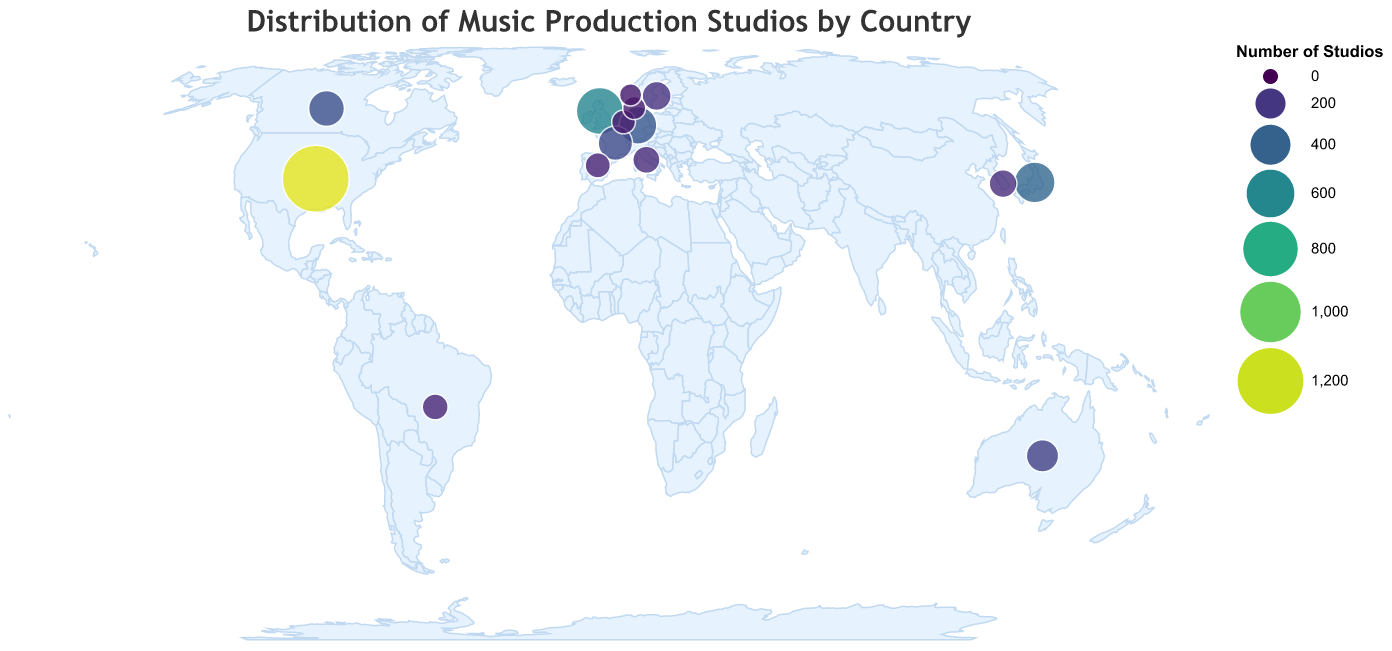How many countries are displayed in the figure? Count each data point in the figure to determine the total number of countries represented. There are 15 data points in the dataset.
Answer: 15 Which country has the highest number of music production studios? Look for the country with the largest circle and the highest tooltip value. The United States has 1250 studios.
Answer: United States What's the total number of music production studios in all the countries combined? Sum each value from all the countries: 1250 + 580 + 420 + 350 + 310 + 280 + 240 + 180 + 160 + 150 + 130 + 120 + 100 + 90 + 80 = 4440 studios.
Answer: 4440 Which country has fewer music production studios, Brazil or Italy? Compare the values next to Brazil and Italy. Brazil has 130 studios, while Italy has 150 studios. Brazil has fewer studios.
Answer: Brazil What is the average number of music production studios per country? Sum the number of studios (4440) and divide by the number of countries (15). (4440/15) = 296 studios.
Answer: 296 Which country in Asia has the most music production studios? Look for countries in Asia and compare their values. Japan has 420 studios and South Korea has 160. Japan has the most studios in Asia.
Answer: Japan Which countries have between 100 and 200 music production studios? Identify the countries whose number of studios falls within the range of 100 to 200. They are Sweden (180), South Korea (160), Italy (150), Brazil (130), and Spain (120).
Answer: Sweden, South Korea, Italy, Brazil, Spain What percentage of the total music production studios does the United States have? (Number of studios in the US / Total number of studios) * 100 = (1250 / 4440) * 100 = 28.15%.
Answer: 28.15% If the number of studios in the United Kingdom increased by 100, what would be the new total for the UK? Add 100 to the current number for the UK (580). 580 + 100 = 680 studios.
Answer: 680 What is the difference in the number of studios between the country with the most and the country with the fewest studios? Subtract the number of studios in Norway (80) from the number in the United States (1250). 1250 - 80 = 1170 studios.
Answer: 1170 